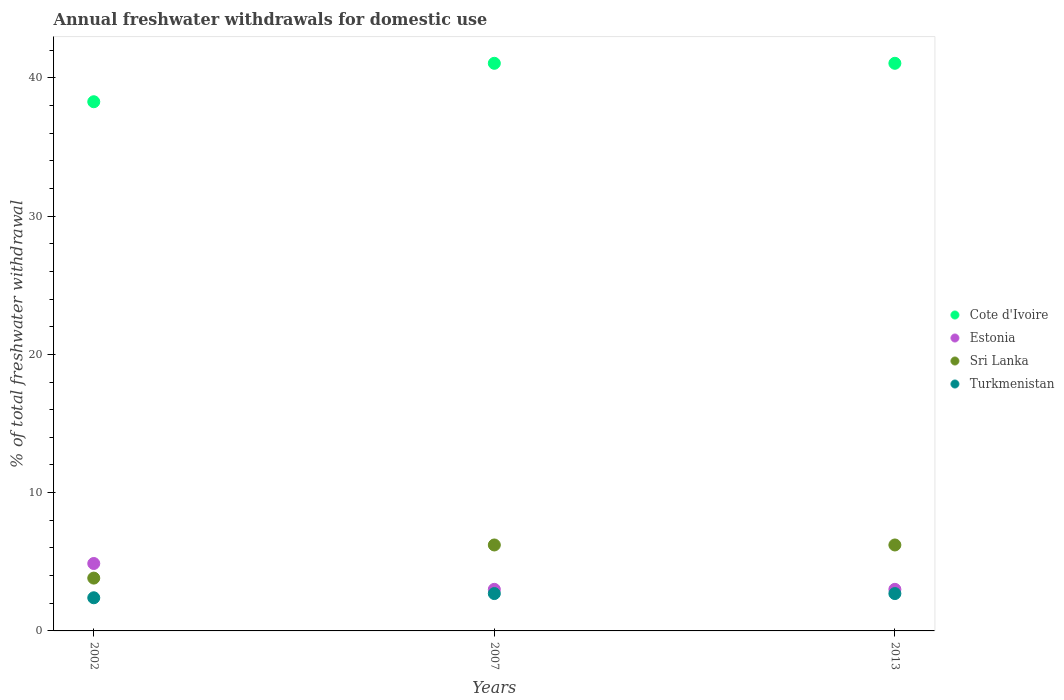Is the number of dotlines equal to the number of legend labels?
Give a very brief answer. Yes. What is the total annual withdrawals from freshwater in Cote d'Ivoire in 2013?
Provide a short and direct response. 41.05. Across all years, what is the maximum total annual withdrawals from freshwater in Sri Lanka?
Offer a very short reply. 6.22. Across all years, what is the minimum total annual withdrawals from freshwater in Sri Lanka?
Give a very brief answer. 3.82. What is the total total annual withdrawals from freshwater in Cote d'Ivoire in the graph?
Make the answer very short. 120.37. What is the difference between the total annual withdrawals from freshwater in Turkmenistan in 2002 and that in 2013?
Provide a short and direct response. -0.3. What is the difference between the total annual withdrawals from freshwater in Estonia in 2013 and the total annual withdrawals from freshwater in Sri Lanka in 2007?
Offer a very short reply. -3.21. What is the average total annual withdrawals from freshwater in Sri Lanka per year?
Give a very brief answer. 5.42. In the year 2007, what is the difference between the total annual withdrawals from freshwater in Turkmenistan and total annual withdrawals from freshwater in Estonia?
Give a very brief answer. -0.31. Is the difference between the total annual withdrawals from freshwater in Turkmenistan in 2002 and 2013 greater than the difference between the total annual withdrawals from freshwater in Estonia in 2002 and 2013?
Provide a succinct answer. No. What is the difference between the highest and the second highest total annual withdrawals from freshwater in Estonia?
Keep it short and to the point. 1.87. What is the difference between the highest and the lowest total annual withdrawals from freshwater in Sri Lanka?
Your answer should be compact. 2.4. In how many years, is the total annual withdrawals from freshwater in Turkmenistan greater than the average total annual withdrawals from freshwater in Turkmenistan taken over all years?
Give a very brief answer. 2. Is the sum of the total annual withdrawals from freshwater in Sri Lanka in 2002 and 2007 greater than the maximum total annual withdrawals from freshwater in Cote d'Ivoire across all years?
Offer a terse response. No. Does the total annual withdrawals from freshwater in Sri Lanka monotonically increase over the years?
Offer a terse response. No. Is the total annual withdrawals from freshwater in Estonia strictly greater than the total annual withdrawals from freshwater in Cote d'Ivoire over the years?
Your answer should be compact. No. How many dotlines are there?
Your answer should be compact. 4. How many years are there in the graph?
Your response must be concise. 3. Are the values on the major ticks of Y-axis written in scientific E-notation?
Provide a succinct answer. No. How are the legend labels stacked?
Your answer should be very brief. Vertical. What is the title of the graph?
Give a very brief answer. Annual freshwater withdrawals for domestic use. What is the label or title of the Y-axis?
Your response must be concise. % of total freshwater withdrawal. What is the % of total freshwater withdrawal of Cote d'Ivoire in 2002?
Provide a succinct answer. 38.27. What is the % of total freshwater withdrawal in Estonia in 2002?
Provide a succinct answer. 4.88. What is the % of total freshwater withdrawal in Sri Lanka in 2002?
Offer a very short reply. 3.82. What is the % of total freshwater withdrawal of Turkmenistan in 2002?
Keep it short and to the point. 2.4. What is the % of total freshwater withdrawal of Cote d'Ivoire in 2007?
Your answer should be very brief. 41.05. What is the % of total freshwater withdrawal in Estonia in 2007?
Make the answer very short. 3.01. What is the % of total freshwater withdrawal of Sri Lanka in 2007?
Your answer should be very brief. 6.22. What is the % of total freshwater withdrawal in Turkmenistan in 2007?
Offer a terse response. 2.7. What is the % of total freshwater withdrawal in Cote d'Ivoire in 2013?
Offer a terse response. 41.05. What is the % of total freshwater withdrawal of Estonia in 2013?
Ensure brevity in your answer.  3.01. What is the % of total freshwater withdrawal in Sri Lanka in 2013?
Keep it short and to the point. 6.22. What is the % of total freshwater withdrawal in Turkmenistan in 2013?
Offer a terse response. 2.7. Across all years, what is the maximum % of total freshwater withdrawal in Cote d'Ivoire?
Ensure brevity in your answer.  41.05. Across all years, what is the maximum % of total freshwater withdrawal of Estonia?
Your answer should be very brief. 4.88. Across all years, what is the maximum % of total freshwater withdrawal in Sri Lanka?
Your answer should be very brief. 6.22. Across all years, what is the maximum % of total freshwater withdrawal of Turkmenistan?
Your answer should be very brief. 2.7. Across all years, what is the minimum % of total freshwater withdrawal in Cote d'Ivoire?
Keep it short and to the point. 38.27. Across all years, what is the minimum % of total freshwater withdrawal in Estonia?
Ensure brevity in your answer.  3.01. Across all years, what is the minimum % of total freshwater withdrawal of Sri Lanka?
Make the answer very short. 3.82. Across all years, what is the minimum % of total freshwater withdrawal in Turkmenistan?
Provide a short and direct response. 2.4. What is the total % of total freshwater withdrawal of Cote d'Ivoire in the graph?
Make the answer very short. 120.37. What is the total % of total freshwater withdrawal of Estonia in the graph?
Provide a succinct answer. 10.89. What is the total % of total freshwater withdrawal of Sri Lanka in the graph?
Offer a very short reply. 16.25. What is the total % of total freshwater withdrawal of Turkmenistan in the graph?
Provide a succinct answer. 7.8. What is the difference between the % of total freshwater withdrawal of Cote d'Ivoire in 2002 and that in 2007?
Give a very brief answer. -2.78. What is the difference between the % of total freshwater withdrawal in Estonia in 2002 and that in 2007?
Provide a short and direct response. 1.87. What is the difference between the % of total freshwater withdrawal in Sri Lanka in 2002 and that in 2007?
Ensure brevity in your answer.  -2.4. What is the difference between the % of total freshwater withdrawal of Turkmenistan in 2002 and that in 2007?
Provide a succinct answer. -0.3. What is the difference between the % of total freshwater withdrawal of Cote d'Ivoire in 2002 and that in 2013?
Keep it short and to the point. -2.78. What is the difference between the % of total freshwater withdrawal in Estonia in 2002 and that in 2013?
Offer a terse response. 1.87. What is the difference between the % of total freshwater withdrawal of Sri Lanka in 2002 and that in 2013?
Your answer should be compact. -2.4. What is the difference between the % of total freshwater withdrawal of Turkmenistan in 2002 and that in 2013?
Offer a terse response. -0.3. What is the difference between the % of total freshwater withdrawal of Estonia in 2007 and that in 2013?
Your response must be concise. 0. What is the difference between the % of total freshwater withdrawal in Cote d'Ivoire in 2002 and the % of total freshwater withdrawal in Estonia in 2007?
Keep it short and to the point. 35.26. What is the difference between the % of total freshwater withdrawal in Cote d'Ivoire in 2002 and the % of total freshwater withdrawal in Sri Lanka in 2007?
Provide a short and direct response. 32.05. What is the difference between the % of total freshwater withdrawal in Cote d'Ivoire in 2002 and the % of total freshwater withdrawal in Turkmenistan in 2007?
Offer a terse response. 35.57. What is the difference between the % of total freshwater withdrawal in Estonia in 2002 and the % of total freshwater withdrawal in Sri Lanka in 2007?
Your answer should be very brief. -1.34. What is the difference between the % of total freshwater withdrawal in Estonia in 2002 and the % of total freshwater withdrawal in Turkmenistan in 2007?
Offer a very short reply. 2.17. What is the difference between the % of total freshwater withdrawal in Sri Lanka in 2002 and the % of total freshwater withdrawal in Turkmenistan in 2007?
Offer a terse response. 1.12. What is the difference between the % of total freshwater withdrawal in Cote d'Ivoire in 2002 and the % of total freshwater withdrawal in Estonia in 2013?
Your answer should be very brief. 35.26. What is the difference between the % of total freshwater withdrawal in Cote d'Ivoire in 2002 and the % of total freshwater withdrawal in Sri Lanka in 2013?
Offer a very short reply. 32.05. What is the difference between the % of total freshwater withdrawal in Cote d'Ivoire in 2002 and the % of total freshwater withdrawal in Turkmenistan in 2013?
Your answer should be very brief. 35.57. What is the difference between the % of total freshwater withdrawal of Estonia in 2002 and the % of total freshwater withdrawal of Sri Lanka in 2013?
Offer a terse response. -1.34. What is the difference between the % of total freshwater withdrawal of Estonia in 2002 and the % of total freshwater withdrawal of Turkmenistan in 2013?
Make the answer very short. 2.17. What is the difference between the % of total freshwater withdrawal of Sri Lanka in 2002 and the % of total freshwater withdrawal of Turkmenistan in 2013?
Offer a very short reply. 1.12. What is the difference between the % of total freshwater withdrawal in Cote d'Ivoire in 2007 and the % of total freshwater withdrawal in Estonia in 2013?
Provide a short and direct response. 38.04. What is the difference between the % of total freshwater withdrawal of Cote d'Ivoire in 2007 and the % of total freshwater withdrawal of Sri Lanka in 2013?
Your answer should be very brief. 34.83. What is the difference between the % of total freshwater withdrawal in Cote d'Ivoire in 2007 and the % of total freshwater withdrawal in Turkmenistan in 2013?
Offer a terse response. 38.35. What is the difference between the % of total freshwater withdrawal in Estonia in 2007 and the % of total freshwater withdrawal in Sri Lanka in 2013?
Offer a terse response. -3.21. What is the difference between the % of total freshwater withdrawal in Estonia in 2007 and the % of total freshwater withdrawal in Turkmenistan in 2013?
Keep it short and to the point. 0.31. What is the difference between the % of total freshwater withdrawal in Sri Lanka in 2007 and the % of total freshwater withdrawal in Turkmenistan in 2013?
Provide a succinct answer. 3.52. What is the average % of total freshwater withdrawal of Cote d'Ivoire per year?
Your response must be concise. 40.12. What is the average % of total freshwater withdrawal of Estonia per year?
Keep it short and to the point. 3.63. What is the average % of total freshwater withdrawal of Sri Lanka per year?
Make the answer very short. 5.42. What is the average % of total freshwater withdrawal of Turkmenistan per year?
Your answer should be very brief. 2.6. In the year 2002, what is the difference between the % of total freshwater withdrawal in Cote d'Ivoire and % of total freshwater withdrawal in Estonia?
Keep it short and to the point. 33.39. In the year 2002, what is the difference between the % of total freshwater withdrawal of Cote d'Ivoire and % of total freshwater withdrawal of Sri Lanka?
Provide a short and direct response. 34.45. In the year 2002, what is the difference between the % of total freshwater withdrawal of Cote d'Ivoire and % of total freshwater withdrawal of Turkmenistan?
Keep it short and to the point. 35.87. In the year 2002, what is the difference between the % of total freshwater withdrawal in Estonia and % of total freshwater withdrawal in Sri Lanka?
Ensure brevity in your answer.  1.06. In the year 2002, what is the difference between the % of total freshwater withdrawal of Estonia and % of total freshwater withdrawal of Turkmenistan?
Keep it short and to the point. 2.48. In the year 2002, what is the difference between the % of total freshwater withdrawal in Sri Lanka and % of total freshwater withdrawal in Turkmenistan?
Provide a succinct answer. 1.42. In the year 2007, what is the difference between the % of total freshwater withdrawal of Cote d'Ivoire and % of total freshwater withdrawal of Estonia?
Make the answer very short. 38.04. In the year 2007, what is the difference between the % of total freshwater withdrawal of Cote d'Ivoire and % of total freshwater withdrawal of Sri Lanka?
Ensure brevity in your answer.  34.83. In the year 2007, what is the difference between the % of total freshwater withdrawal in Cote d'Ivoire and % of total freshwater withdrawal in Turkmenistan?
Offer a terse response. 38.35. In the year 2007, what is the difference between the % of total freshwater withdrawal in Estonia and % of total freshwater withdrawal in Sri Lanka?
Provide a succinct answer. -3.21. In the year 2007, what is the difference between the % of total freshwater withdrawal of Estonia and % of total freshwater withdrawal of Turkmenistan?
Provide a succinct answer. 0.31. In the year 2007, what is the difference between the % of total freshwater withdrawal of Sri Lanka and % of total freshwater withdrawal of Turkmenistan?
Your answer should be very brief. 3.52. In the year 2013, what is the difference between the % of total freshwater withdrawal of Cote d'Ivoire and % of total freshwater withdrawal of Estonia?
Your answer should be very brief. 38.04. In the year 2013, what is the difference between the % of total freshwater withdrawal in Cote d'Ivoire and % of total freshwater withdrawal in Sri Lanka?
Offer a very short reply. 34.83. In the year 2013, what is the difference between the % of total freshwater withdrawal in Cote d'Ivoire and % of total freshwater withdrawal in Turkmenistan?
Provide a succinct answer. 38.35. In the year 2013, what is the difference between the % of total freshwater withdrawal of Estonia and % of total freshwater withdrawal of Sri Lanka?
Your response must be concise. -3.21. In the year 2013, what is the difference between the % of total freshwater withdrawal of Estonia and % of total freshwater withdrawal of Turkmenistan?
Keep it short and to the point. 0.31. In the year 2013, what is the difference between the % of total freshwater withdrawal in Sri Lanka and % of total freshwater withdrawal in Turkmenistan?
Keep it short and to the point. 3.52. What is the ratio of the % of total freshwater withdrawal of Cote d'Ivoire in 2002 to that in 2007?
Make the answer very short. 0.93. What is the ratio of the % of total freshwater withdrawal in Estonia in 2002 to that in 2007?
Offer a terse response. 1.62. What is the ratio of the % of total freshwater withdrawal in Sri Lanka in 2002 to that in 2007?
Your response must be concise. 0.61. What is the ratio of the % of total freshwater withdrawal in Turkmenistan in 2002 to that in 2007?
Your answer should be very brief. 0.89. What is the ratio of the % of total freshwater withdrawal in Cote d'Ivoire in 2002 to that in 2013?
Your response must be concise. 0.93. What is the ratio of the % of total freshwater withdrawal in Estonia in 2002 to that in 2013?
Ensure brevity in your answer.  1.62. What is the ratio of the % of total freshwater withdrawal in Sri Lanka in 2002 to that in 2013?
Your response must be concise. 0.61. What is the ratio of the % of total freshwater withdrawal of Turkmenistan in 2002 to that in 2013?
Your response must be concise. 0.89. What is the ratio of the % of total freshwater withdrawal in Estonia in 2007 to that in 2013?
Ensure brevity in your answer.  1. What is the ratio of the % of total freshwater withdrawal of Sri Lanka in 2007 to that in 2013?
Keep it short and to the point. 1. What is the difference between the highest and the second highest % of total freshwater withdrawal in Cote d'Ivoire?
Offer a terse response. 0. What is the difference between the highest and the second highest % of total freshwater withdrawal of Estonia?
Provide a short and direct response. 1.87. What is the difference between the highest and the second highest % of total freshwater withdrawal in Sri Lanka?
Your answer should be very brief. 0. What is the difference between the highest and the lowest % of total freshwater withdrawal of Cote d'Ivoire?
Ensure brevity in your answer.  2.78. What is the difference between the highest and the lowest % of total freshwater withdrawal in Estonia?
Your answer should be very brief. 1.87. What is the difference between the highest and the lowest % of total freshwater withdrawal of Sri Lanka?
Ensure brevity in your answer.  2.4. What is the difference between the highest and the lowest % of total freshwater withdrawal in Turkmenistan?
Ensure brevity in your answer.  0.3. 